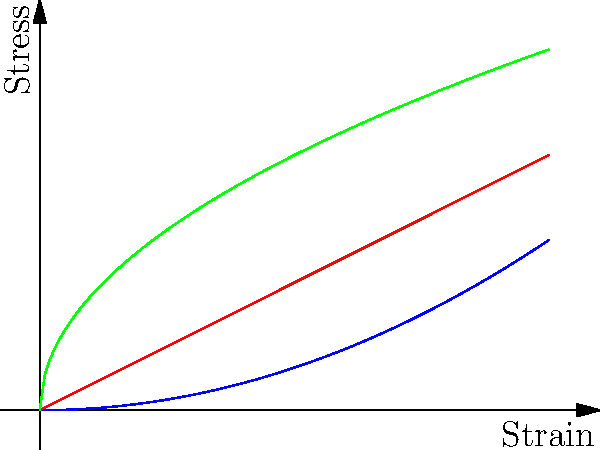Based on the stress-strain curves shown for bone, tendon, and ligament, which tissue exhibits the highest stiffness in the linear region of its stress-strain curve? To determine which tissue has the highest stiffness, we need to analyze the stress-strain curves for each tissue:

1. Recall that stiffness is represented by the slope of the stress-strain curve in its linear region.

2. Bone (blue curve):
   - Exhibits a parabolic shape ($$\sigma \propto \varepsilon^2$$)
   - The slope increases with strain, indicating non-linear behavior

3. Tendon (red curve):
   - Shows a linear relationship between stress and strain
   - The slope is constant throughout, representing linear elastic behavior

4. Ligament (green curve):
   - Displays a curve that flattens out as strain increases
   - The slope decreases with increasing strain

5. Comparing the slopes in the linear regions:
   - Bone has the steepest slope in its initial linear region
   - Tendon has a constant, moderate slope
   - Ligament has the least steep slope

6. The tissue with the steepest slope in its linear region will have the highest stiffness.

Therefore, bone exhibits the highest stiffness in the linear region of its stress-strain curve.
Answer: Bone 